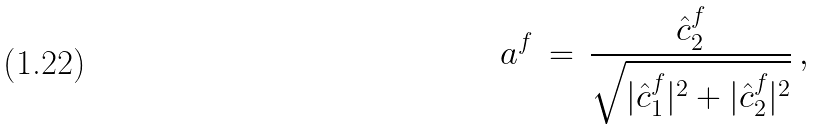<formula> <loc_0><loc_0><loc_500><loc_500>a ^ { f } \, = \, \frac { \hat { c } ^ { f } _ { 2 } } { \sqrt { | \hat { c } _ { 1 } ^ { f } | ^ { 2 } + | \hat { c } _ { 2 } ^ { f } | ^ { 2 } } } \, ,</formula> 